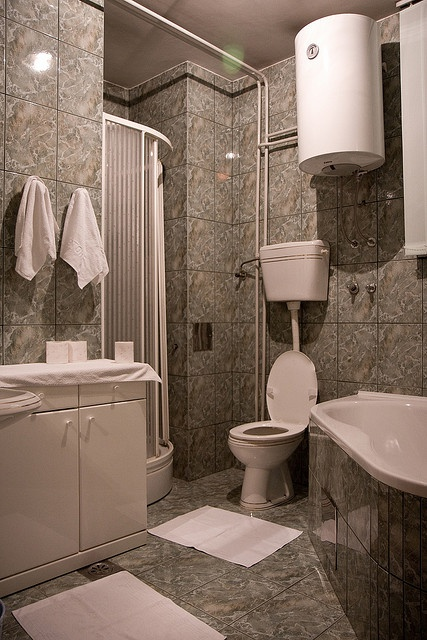Describe the objects in this image and their specific colors. I can see toilet in gray, tan, and black tones and sink in gray, darkgray, and tan tones in this image. 